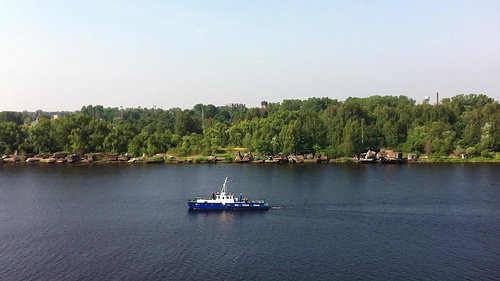Please provide the bounding box coordinate of the region this sentence describes: boat dock. The boat dock located at [0.45, 0.51, 0.52, 0.55] features a sturdy wooden structure with mooring posts visible, providing anchorage for small boats. 